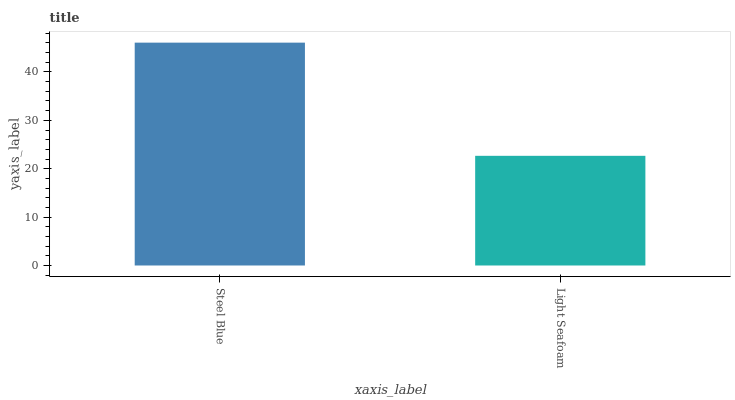Is Light Seafoam the maximum?
Answer yes or no. No. Is Steel Blue greater than Light Seafoam?
Answer yes or no. Yes. Is Light Seafoam less than Steel Blue?
Answer yes or no. Yes. Is Light Seafoam greater than Steel Blue?
Answer yes or no. No. Is Steel Blue less than Light Seafoam?
Answer yes or no. No. Is Steel Blue the high median?
Answer yes or no. Yes. Is Light Seafoam the low median?
Answer yes or no. Yes. Is Light Seafoam the high median?
Answer yes or no. No. Is Steel Blue the low median?
Answer yes or no. No. 